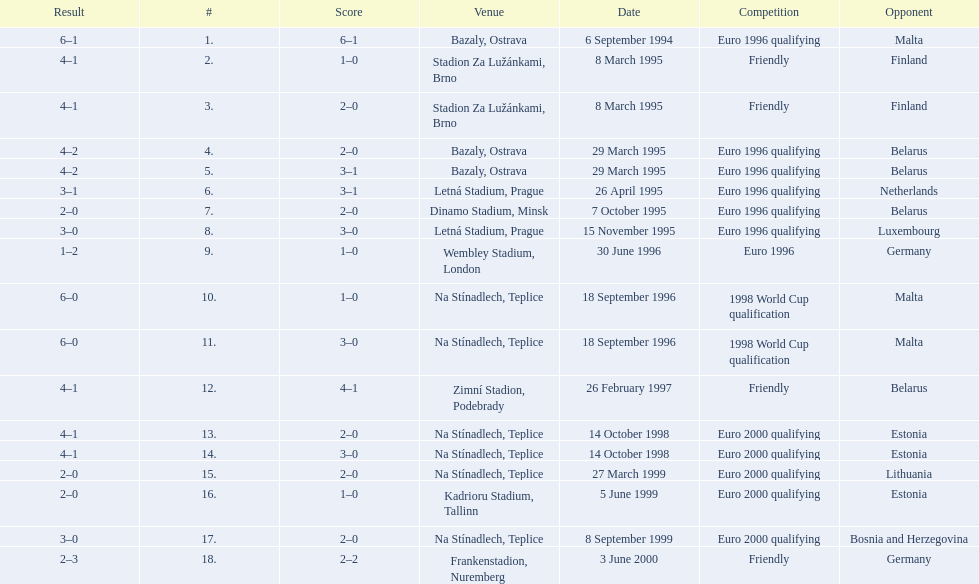What opponent is listed last on the table? Germany. 